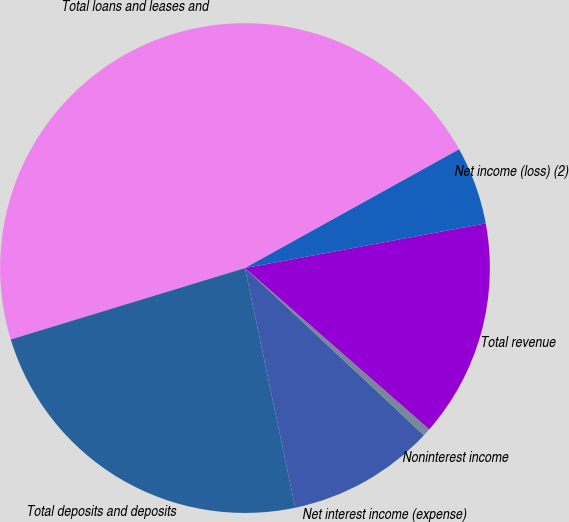<chart> <loc_0><loc_0><loc_500><loc_500><pie_chart><fcel>Total loans and leases and<fcel>Total deposits and deposits<fcel>Net interest income (expense)<fcel>Noninterest income<fcel>Total revenue<fcel>Net income (loss) (2)<nl><fcel>46.65%<fcel>23.58%<fcel>9.75%<fcel>0.52%<fcel>14.36%<fcel>5.14%<nl></chart> 